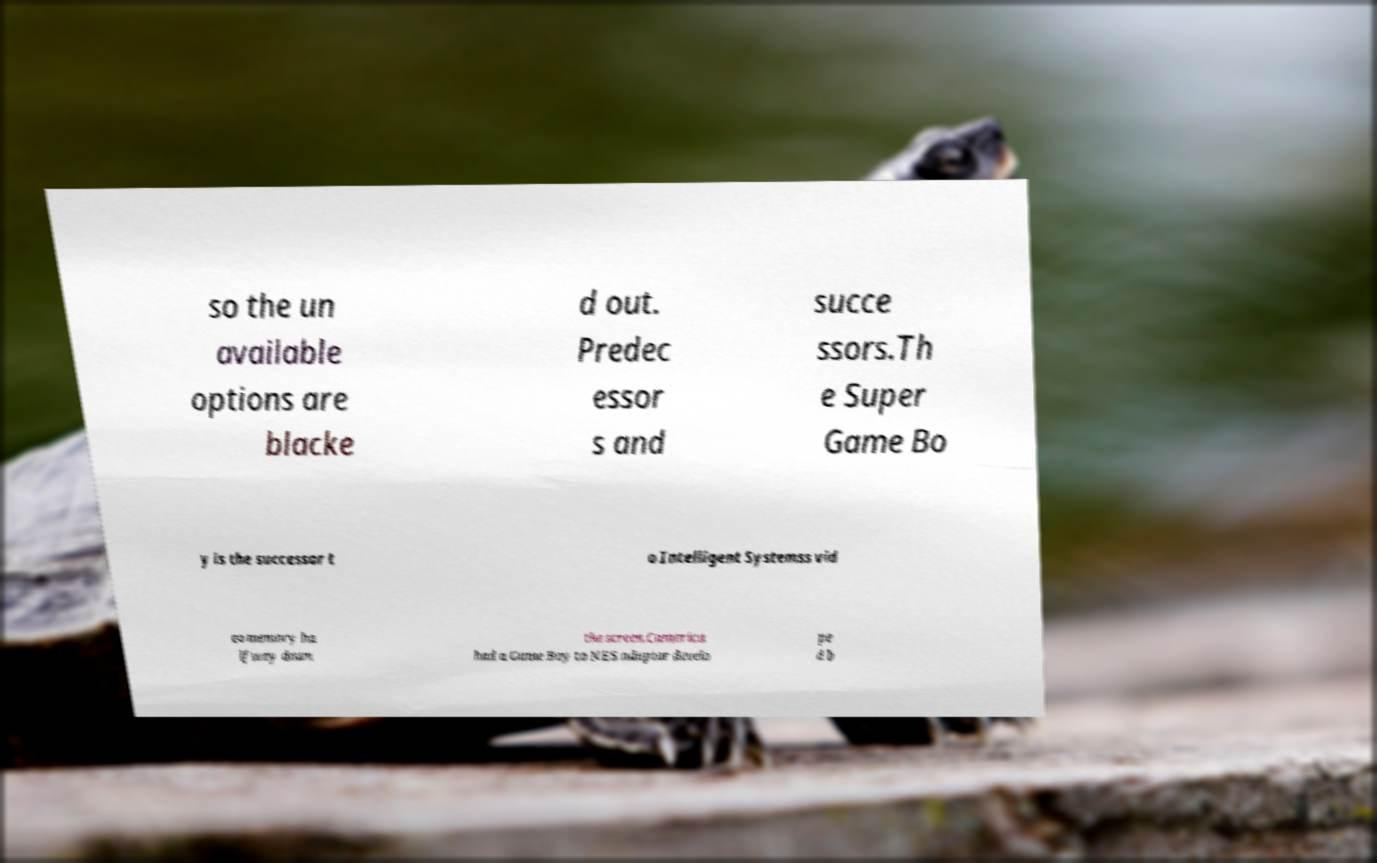Could you extract and type out the text from this image? so the un available options are blacke d out. Predec essor s and succe ssors.Th e Super Game Bo y is the successor t o Intelligent Systemss vid eo memory ha lfway down the screen.Camerica had a Game Boy to NES adaptor develo pe d b 